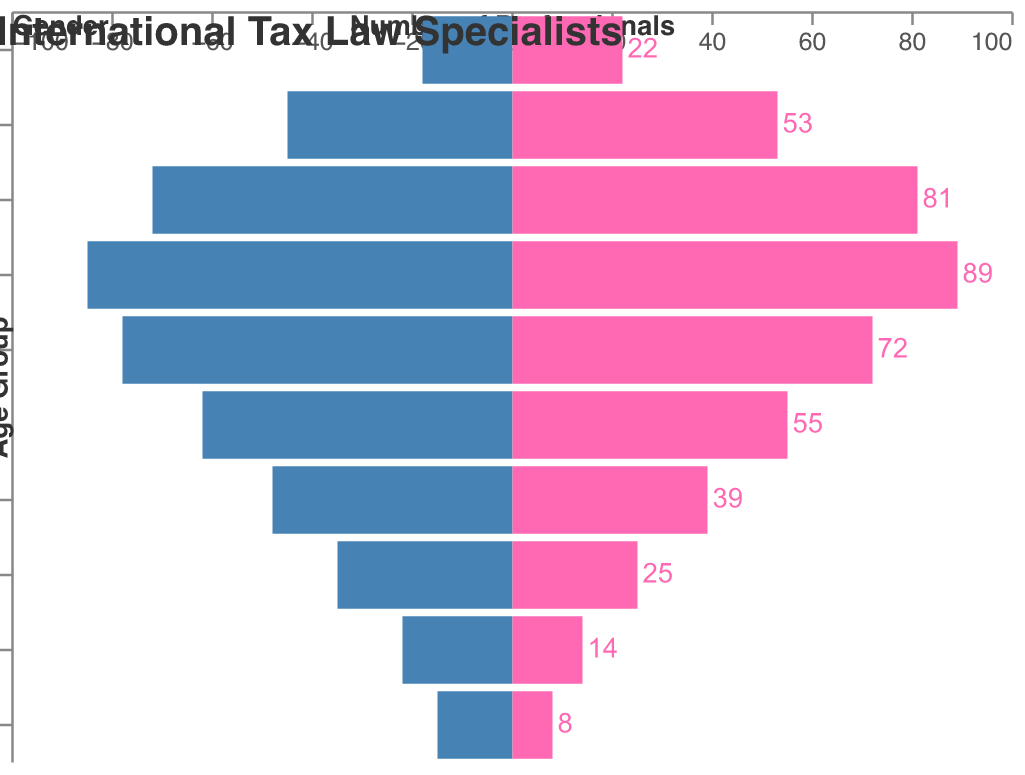How many age groups are represented in the population pyramid? Counting the labels on the y-axis, we see different age groups: 65+, 60-64, 55-59, 50-54, 45-49, 40-44, 35-39, 30-34, 25-29, and 20-24. This sums up to 10 different age groups.
Answer: 10 Which gender has the highest number of professionals in the 35-39 age group? By looking at the horizontal bars in the 35-39 age group, the number of males is slightly lower than the number of females. Female professionals are 89, while male professionals are 85.
Answer: Female What is the total number of male professionals aged 45-49 and 50-54? The number of male professionals aged 45-49 is 62, and the number of male professionals aged 50-54 is 48. Summing these gives 62 + 48 = 110.
Answer: 110 What is the difference between the number of female professionals in the 30-34 and 25-29 age groups? The number of female professionals in the 30-34 age group is 81, while in the 25-29 age group is 53. The difference is 81 - 53 = 28.
Answer: 28 In which age group do you find the largest disparity in gender representation? By comparing the lengths of the bars for each age group, the 35-39 age group seems to have the largest difference between the number of male (85) and female (89) professionals, with a difference of 4.
Answer: 35-39 Which age group has the least number of professionals for both genders combined? Summing the number of professionals for each age group, the 65+ age group has 15 (male) + 8 (female) = 23 professionals, which is the least among all groups.
Answer: 65+ How does the number of male professionals in the 40-44 age group compare to the number in the 60-64 age group? The number of male professionals in the 40-44 age group is 78, while in the 60-64 age group it is 22. 78 is significantly larger than 22.
Answer: 40-44 has more What is the sum of the number of female professionals in the 55-59 and 60-64 age groups? The number of female professionals in the 55-59 age group is 25, and in the 60-64 age group is 14. Summing these gives 25 + 14 = 39.
Answer: 39 Does any age group have an equal number of male and female professionals? Looking at all age groups, none of them have equal bars for both male and female professionals.
Answer: No 